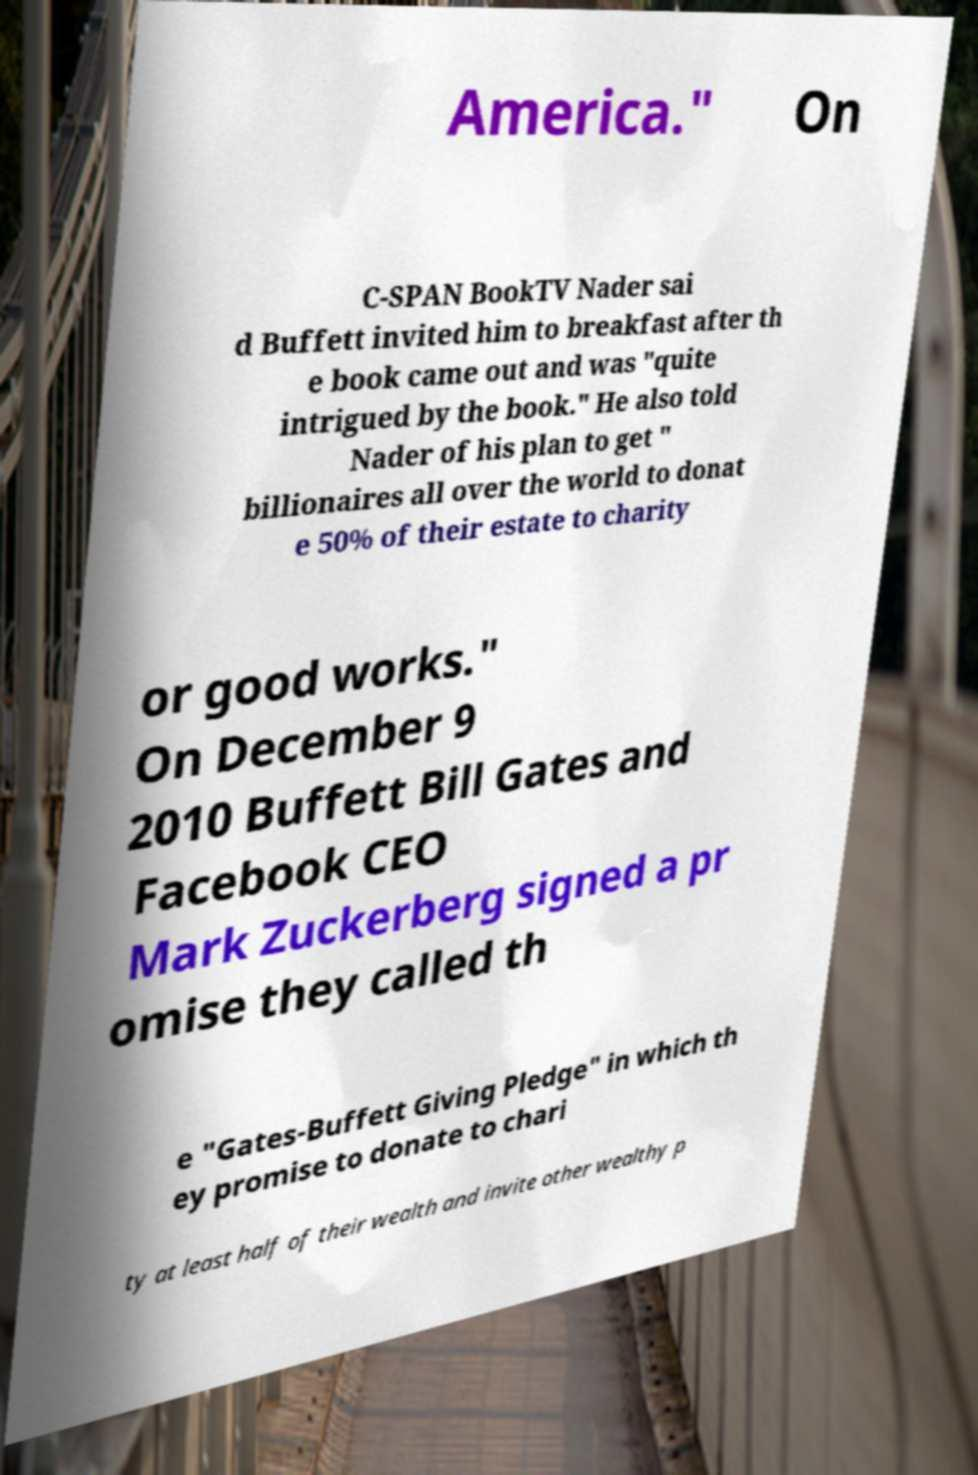Can you read and provide the text displayed in the image?This photo seems to have some interesting text. Can you extract and type it out for me? America." On C-SPAN BookTV Nader sai d Buffett invited him to breakfast after th e book came out and was "quite intrigued by the book." He also told Nader of his plan to get " billionaires all over the world to donat e 50% of their estate to charity or good works." On December 9 2010 Buffett Bill Gates and Facebook CEO Mark Zuckerberg signed a pr omise they called th e "Gates-Buffett Giving Pledge" in which th ey promise to donate to chari ty at least half of their wealth and invite other wealthy p 